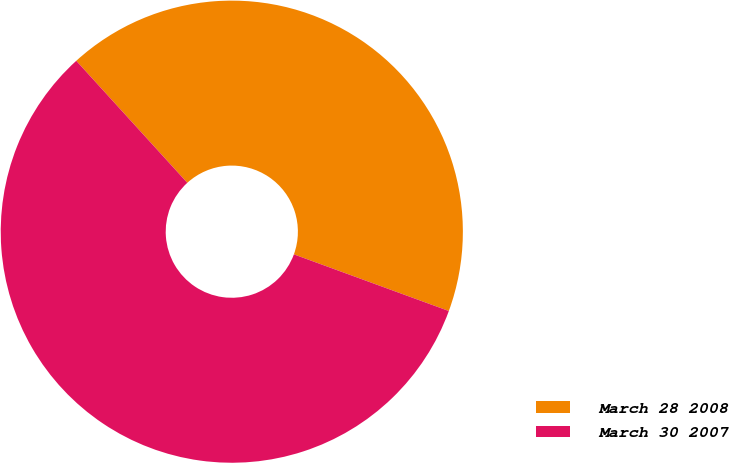<chart> <loc_0><loc_0><loc_500><loc_500><pie_chart><fcel>March 28 2008<fcel>March 30 2007<nl><fcel>42.33%<fcel>57.67%<nl></chart> 